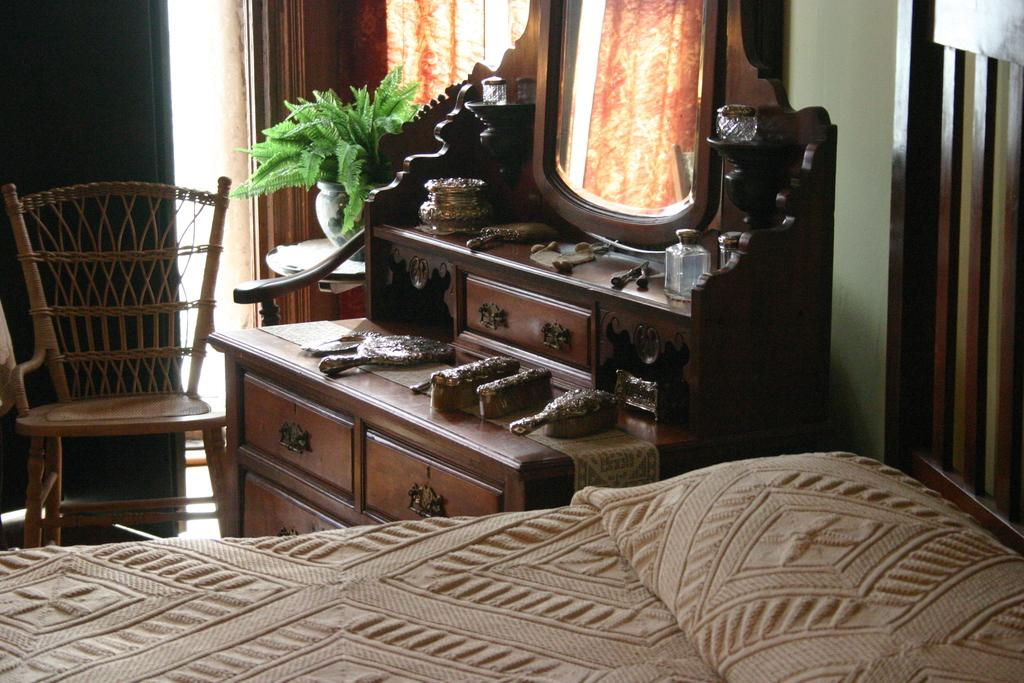What type of furniture is present in the image? There is a bed, a chair, and a dressing table in the image. What other object can be seen in the image? There is a plant in the image. Can you describe the purpose of each piece of furniture? The bed is likely for sleeping, the chair is for sitting, and the dressing table is for personal grooming. What type of acoustics can be heard in the room from the image? There is no information about the acoustics in the room provided in the image. Are there any ants visible in the image? There are no ants present in the image. 